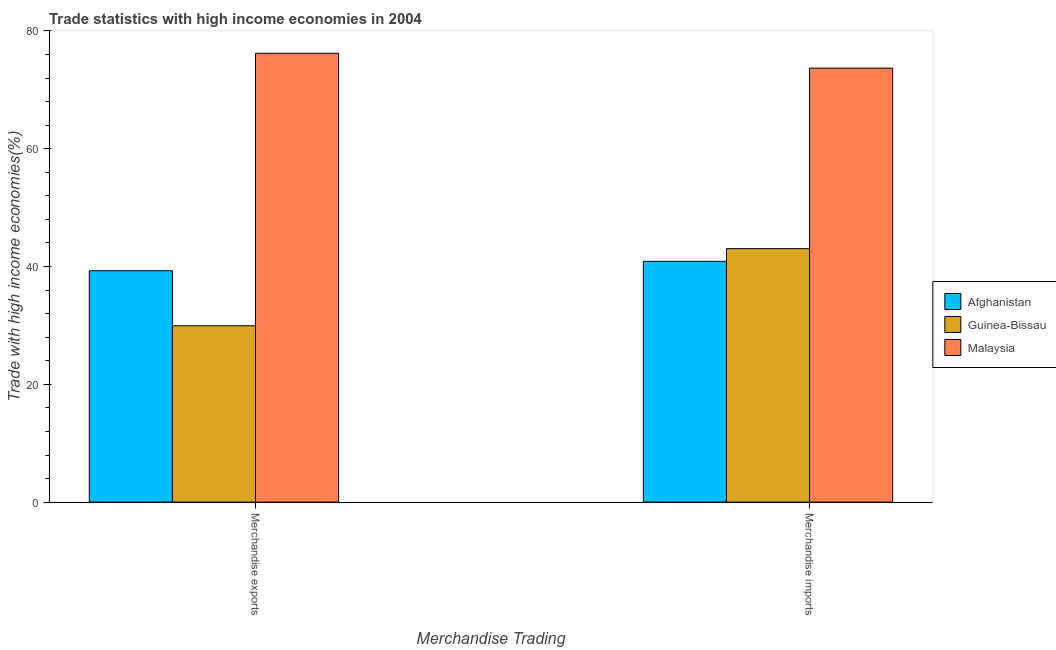How many different coloured bars are there?
Offer a terse response. 3. Are the number of bars per tick equal to the number of legend labels?
Your response must be concise. Yes. Are the number of bars on each tick of the X-axis equal?
Provide a succinct answer. Yes. How many bars are there on the 2nd tick from the left?
Your answer should be compact. 3. What is the label of the 2nd group of bars from the left?
Provide a succinct answer. Merchandise imports. What is the merchandise imports in Guinea-Bissau?
Make the answer very short. 43.04. Across all countries, what is the maximum merchandise exports?
Offer a very short reply. 76.22. Across all countries, what is the minimum merchandise imports?
Ensure brevity in your answer.  40.89. In which country was the merchandise exports maximum?
Offer a terse response. Malaysia. In which country was the merchandise imports minimum?
Your answer should be compact. Afghanistan. What is the total merchandise imports in the graph?
Your response must be concise. 157.62. What is the difference between the merchandise imports in Malaysia and that in Guinea-Bissau?
Keep it short and to the point. 30.66. What is the difference between the merchandise imports in Afghanistan and the merchandise exports in Guinea-Bissau?
Provide a short and direct response. 10.94. What is the average merchandise exports per country?
Give a very brief answer. 48.49. What is the difference between the merchandise imports and merchandise exports in Malaysia?
Offer a very short reply. -2.52. What is the ratio of the merchandise imports in Afghanistan to that in Guinea-Bissau?
Offer a terse response. 0.95. In how many countries, is the merchandise imports greater than the average merchandise imports taken over all countries?
Provide a succinct answer. 1. What does the 2nd bar from the left in Merchandise exports represents?
Offer a very short reply. Guinea-Bissau. What does the 1st bar from the right in Merchandise exports represents?
Make the answer very short. Malaysia. Are all the bars in the graph horizontal?
Make the answer very short. No. How many countries are there in the graph?
Your response must be concise. 3. Are the values on the major ticks of Y-axis written in scientific E-notation?
Give a very brief answer. No. How many legend labels are there?
Keep it short and to the point. 3. What is the title of the graph?
Provide a succinct answer. Trade statistics with high income economies in 2004. Does "Tajikistan" appear as one of the legend labels in the graph?
Your response must be concise. No. What is the label or title of the X-axis?
Make the answer very short. Merchandise Trading. What is the label or title of the Y-axis?
Offer a terse response. Trade with high income economies(%). What is the Trade with high income economies(%) in Afghanistan in Merchandise exports?
Ensure brevity in your answer.  39.29. What is the Trade with high income economies(%) in Guinea-Bissau in Merchandise exports?
Offer a terse response. 29.95. What is the Trade with high income economies(%) of Malaysia in Merchandise exports?
Give a very brief answer. 76.22. What is the Trade with high income economies(%) of Afghanistan in Merchandise imports?
Your answer should be compact. 40.89. What is the Trade with high income economies(%) in Guinea-Bissau in Merchandise imports?
Give a very brief answer. 43.04. What is the Trade with high income economies(%) of Malaysia in Merchandise imports?
Your answer should be very brief. 73.69. Across all Merchandise Trading, what is the maximum Trade with high income economies(%) in Afghanistan?
Give a very brief answer. 40.89. Across all Merchandise Trading, what is the maximum Trade with high income economies(%) in Guinea-Bissau?
Provide a succinct answer. 43.04. Across all Merchandise Trading, what is the maximum Trade with high income economies(%) in Malaysia?
Your response must be concise. 76.22. Across all Merchandise Trading, what is the minimum Trade with high income economies(%) in Afghanistan?
Offer a very short reply. 39.29. Across all Merchandise Trading, what is the minimum Trade with high income economies(%) in Guinea-Bissau?
Your answer should be very brief. 29.95. Across all Merchandise Trading, what is the minimum Trade with high income economies(%) in Malaysia?
Offer a terse response. 73.69. What is the total Trade with high income economies(%) of Afghanistan in the graph?
Ensure brevity in your answer.  80.18. What is the total Trade with high income economies(%) of Guinea-Bissau in the graph?
Offer a very short reply. 72.98. What is the total Trade with high income economies(%) of Malaysia in the graph?
Provide a short and direct response. 149.91. What is the difference between the Trade with high income economies(%) in Afghanistan in Merchandise exports and that in Merchandise imports?
Your response must be concise. -1.59. What is the difference between the Trade with high income economies(%) of Guinea-Bissau in Merchandise exports and that in Merchandise imports?
Your response must be concise. -13.09. What is the difference between the Trade with high income economies(%) in Malaysia in Merchandise exports and that in Merchandise imports?
Your answer should be compact. 2.52. What is the difference between the Trade with high income economies(%) of Afghanistan in Merchandise exports and the Trade with high income economies(%) of Guinea-Bissau in Merchandise imports?
Ensure brevity in your answer.  -3.74. What is the difference between the Trade with high income economies(%) in Afghanistan in Merchandise exports and the Trade with high income economies(%) in Malaysia in Merchandise imports?
Offer a terse response. -34.4. What is the difference between the Trade with high income economies(%) of Guinea-Bissau in Merchandise exports and the Trade with high income economies(%) of Malaysia in Merchandise imports?
Keep it short and to the point. -43.75. What is the average Trade with high income economies(%) in Afghanistan per Merchandise Trading?
Make the answer very short. 40.09. What is the average Trade with high income economies(%) of Guinea-Bissau per Merchandise Trading?
Offer a terse response. 36.49. What is the average Trade with high income economies(%) in Malaysia per Merchandise Trading?
Give a very brief answer. 74.95. What is the difference between the Trade with high income economies(%) in Afghanistan and Trade with high income economies(%) in Guinea-Bissau in Merchandise exports?
Make the answer very short. 9.35. What is the difference between the Trade with high income economies(%) of Afghanistan and Trade with high income economies(%) of Malaysia in Merchandise exports?
Give a very brief answer. -36.92. What is the difference between the Trade with high income economies(%) of Guinea-Bissau and Trade with high income economies(%) of Malaysia in Merchandise exports?
Provide a succinct answer. -46.27. What is the difference between the Trade with high income economies(%) in Afghanistan and Trade with high income economies(%) in Guinea-Bissau in Merchandise imports?
Provide a short and direct response. -2.15. What is the difference between the Trade with high income economies(%) in Afghanistan and Trade with high income economies(%) in Malaysia in Merchandise imports?
Keep it short and to the point. -32.81. What is the difference between the Trade with high income economies(%) in Guinea-Bissau and Trade with high income economies(%) in Malaysia in Merchandise imports?
Your answer should be very brief. -30.66. What is the ratio of the Trade with high income economies(%) in Guinea-Bissau in Merchandise exports to that in Merchandise imports?
Your response must be concise. 0.7. What is the ratio of the Trade with high income economies(%) in Malaysia in Merchandise exports to that in Merchandise imports?
Give a very brief answer. 1.03. What is the difference between the highest and the second highest Trade with high income economies(%) of Afghanistan?
Your answer should be compact. 1.59. What is the difference between the highest and the second highest Trade with high income economies(%) of Guinea-Bissau?
Provide a succinct answer. 13.09. What is the difference between the highest and the second highest Trade with high income economies(%) in Malaysia?
Ensure brevity in your answer.  2.52. What is the difference between the highest and the lowest Trade with high income economies(%) in Afghanistan?
Keep it short and to the point. 1.59. What is the difference between the highest and the lowest Trade with high income economies(%) in Guinea-Bissau?
Offer a terse response. 13.09. What is the difference between the highest and the lowest Trade with high income economies(%) in Malaysia?
Your answer should be compact. 2.52. 